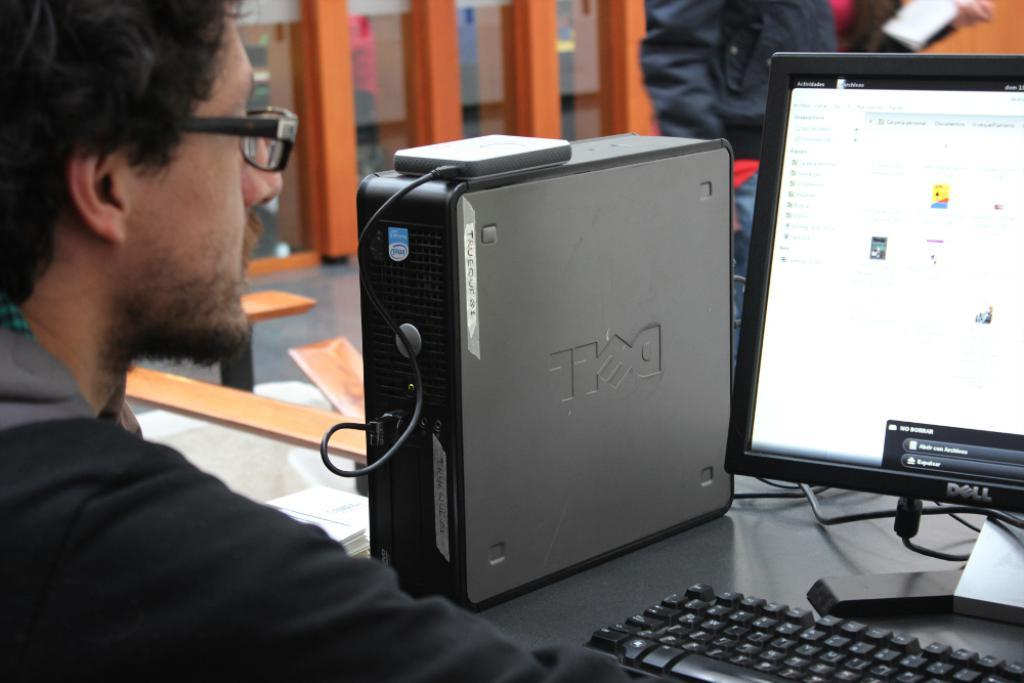<image>
Relay a brief, clear account of the picture shown. A young man intently working at his Dell personal computer. 